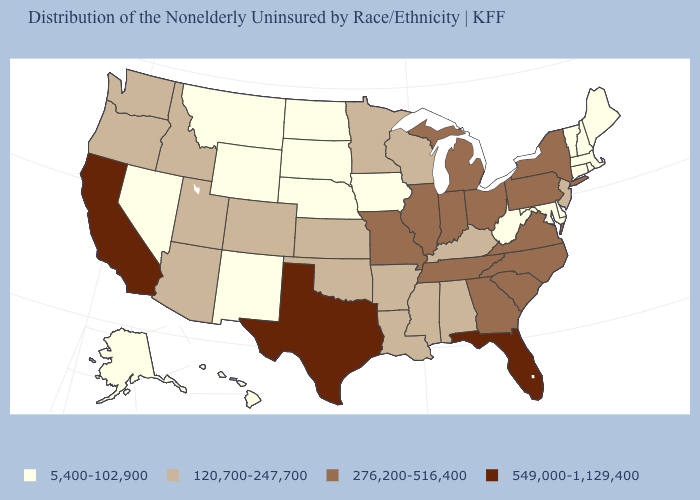Does Texas have the highest value in the USA?
Give a very brief answer. Yes. Name the states that have a value in the range 5,400-102,900?
Concise answer only. Alaska, Connecticut, Delaware, Hawaii, Iowa, Maine, Maryland, Massachusetts, Montana, Nebraska, Nevada, New Hampshire, New Mexico, North Dakota, Rhode Island, South Dakota, Vermont, West Virginia, Wyoming. What is the value of Virginia?
Be succinct. 276,200-516,400. Does the map have missing data?
Answer briefly. No. Name the states that have a value in the range 276,200-516,400?
Keep it brief. Georgia, Illinois, Indiana, Michigan, Missouri, New York, North Carolina, Ohio, Pennsylvania, South Carolina, Tennessee, Virginia. Which states have the lowest value in the USA?
Quick response, please. Alaska, Connecticut, Delaware, Hawaii, Iowa, Maine, Maryland, Massachusetts, Montana, Nebraska, Nevada, New Hampshire, New Mexico, North Dakota, Rhode Island, South Dakota, Vermont, West Virginia, Wyoming. What is the value of New Mexico?
Answer briefly. 5,400-102,900. Name the states that have a value in the range 5,400-102,900?
Write a very short answer. Alaska, Connecticut, Delaware, Hawaii, Iowa, Maine, Maryland, Massachusetts, Montana, Nebraska, Nevada, New Hampshire, New Mexico, North Dakota, Rhode Island, South Dakota, Vermont, West Virginia, Wyoming. What is the value of Georgia?
Answer briefly. 276,200-516,400. What is the value of Wisconsin?
Be succinct. 120,700-247,700. What is the lowest value in states that border Wisconsin?
Write a very short answer. 5,400-102,900. What is the value of Hawaii?
Be succinct. 5,400-102,900. Does Wyoming have a higher value than Nebraska?
Short answer required. No. Which states have the lowest value in the South?
Write a very short answer. Delaware, Maryland, West Virginia. Name the states that have a value in the range 120,700-247,700?
Answer briefly. Alabama, Arizona, Arkansas, Colorado, Idaho, Kansas, Kentucky, Louisiana, Minnesota, Mississippi, New Jersey, Oklahoma, Oregon, Utah, Washington, Wisconsin. 